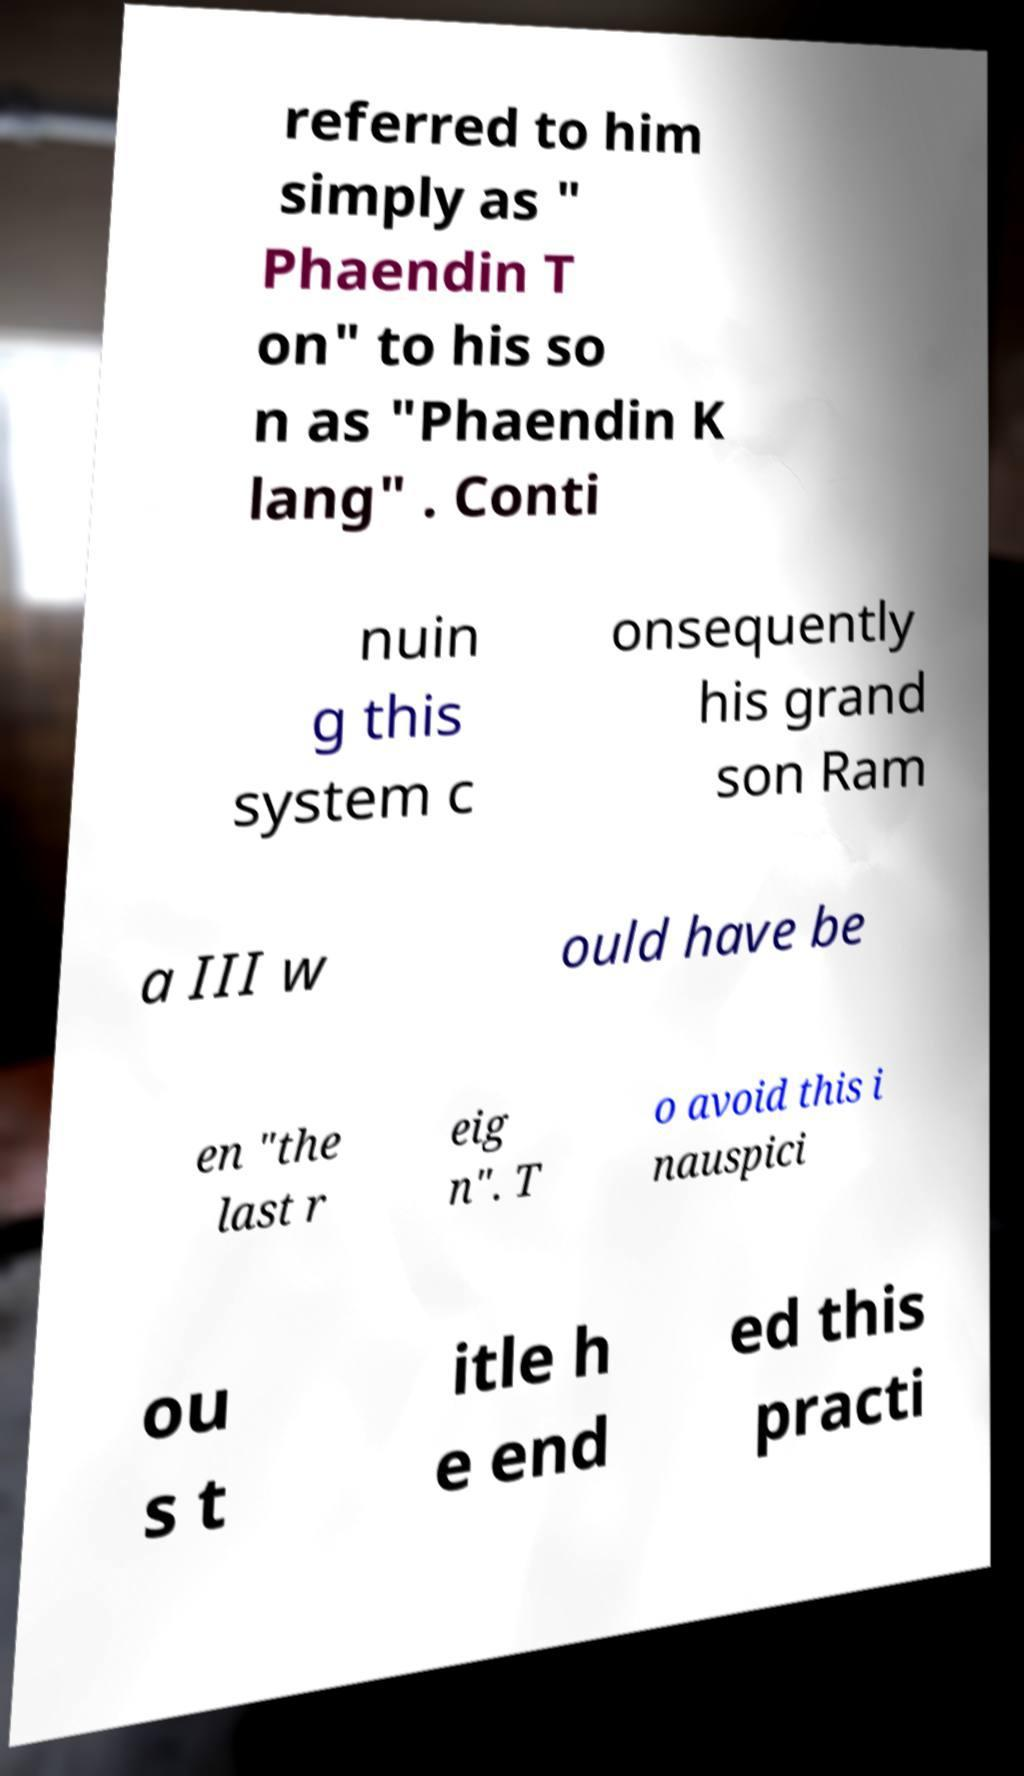What messages or text are displayed in this image? I need them in a readable, typed format. referred to him simply as " Phaendin T on" to his so n as "Phaendin K lang" . Conti nuin g this system c onsequently his grand son Ram a III w ould have be en "the last r eig n". T o avoid this i nauspici ou s t itle h e end ed this practi 